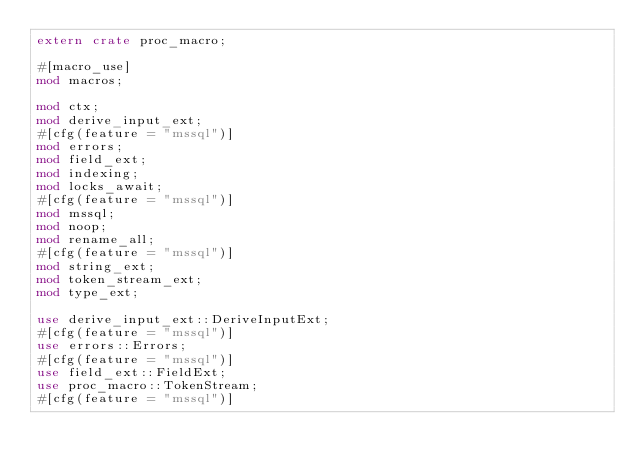Convert code to text. <code><loc_0><loc_0><loc_500><loc_500><_Rust_>extern crate proc_macro;

#[macro_use]
mod macros;

mod ctx;
mod derive_input_ext;
#[cfg(feature = "mssql")]
mod errors;
mod field_ext;
mod indexing;
mod locks_await;
#[cfg(feature = "mssql")]
mod mssql;
mod noop;
mod rename_all;
#[cfg(feature = "mssql")]
mod string_ext;
mod token_stream_ext;
mod type_ext;

use derive_input_ext::DeriveInputExt;
#[cfg(feature = "mssql")]
use errors::Errors;
#[cfg(feature = "mssql")]
use field_ext::FieldExt;
use proc_macro::TokenStream;
#[cfg(feature = "mssql")]</code> 